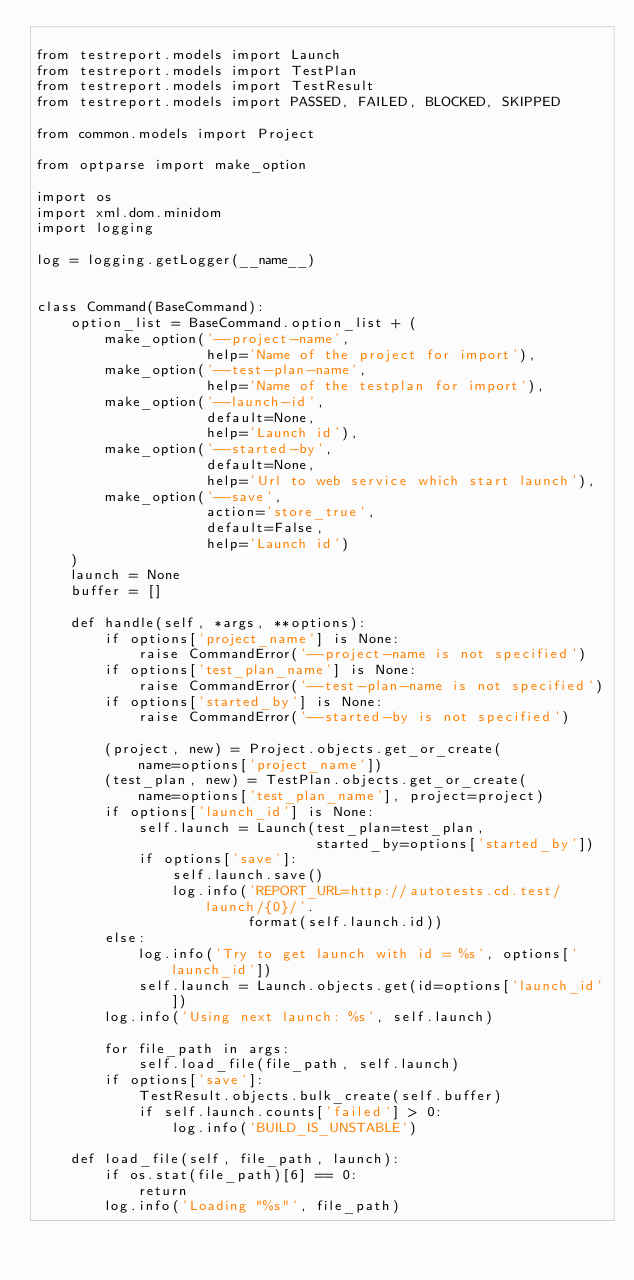Convert code to text. <code><loc_0><loc_0><loc_500><loc_500><_Python_>
from testreport.models import Launch
from testreport.models import TestPlan
from testreport.models import TestResult
from testreport.models import PASSED, FAILED, BLOCKED, SKIPPED

from common.models import Project

from optparse import make_option

import os
import xml.dom.minidom
import logging

log = logging.getLogger(__name__)


class Command(BaseCommand):
    option_list = BaseCommand.option_list + (
        make_option('--project-name',
                    help='Name of the project for import'),
        make_option('--test-plan-name',
                    help='Name of the testplan for import'),
        make_option('--launch-id',
                    default=None,
                    help='Launch id'),
        make_option('--started-by',
                    default=None,
                    help='Url to web service which start launch'),
        make_option('--save',
                    action='store_true',
                    default=False,
                    help='Launch id')
    )
    launch = None
    buffer = []

    def handle(self, *args, **options):
        if options['project_name'] is None:
            raise CommandError('--project-name is not specified')
        if options['test_plan_name'] is None:
            raise CommandError('--test-plan-name is not specified')
        if options['started_by'] is None:
            raise CommandError('--started-by is not specified')

        (project, new) = Project.objects.get_or_create(
            name=options['project_name'])
        (test_plan, new) = TestPlan.objects.get_or_create(
            name=options['test_plan_name'], project=project)
        if options['launch_id'] is None:
            self.launch = Launch(test_plan=test_plan,
                                 started_by=options['started_by'])
            if options['save']:
                self.launch.save()
                log.info('REPORT_URL=http://autotests.cd.test/launch/{0}/'.
                         format(self.launch.id))
        else:
            log.info('Try to get launch with id = %s', options['launch_id'])
            self.launch = Launch.objects.get(id=options['launch_id'])
        log.info('Using next launch: %s', self.launch)

        for file_path in args:
            self.load_file(file_path, self.launch)
        if options['save']:
            TestResult.objects.bulk_create(self.buffer)
            if self.launch.counts['failed'] > 0:
                log.info('BUILD_IS_UNSTABLE')

    def load_file(self, file_path, launch):
        if os.stat(file_path)[6] == 0:
            return
        log.info('Loading "%s"', file_path)</code> 